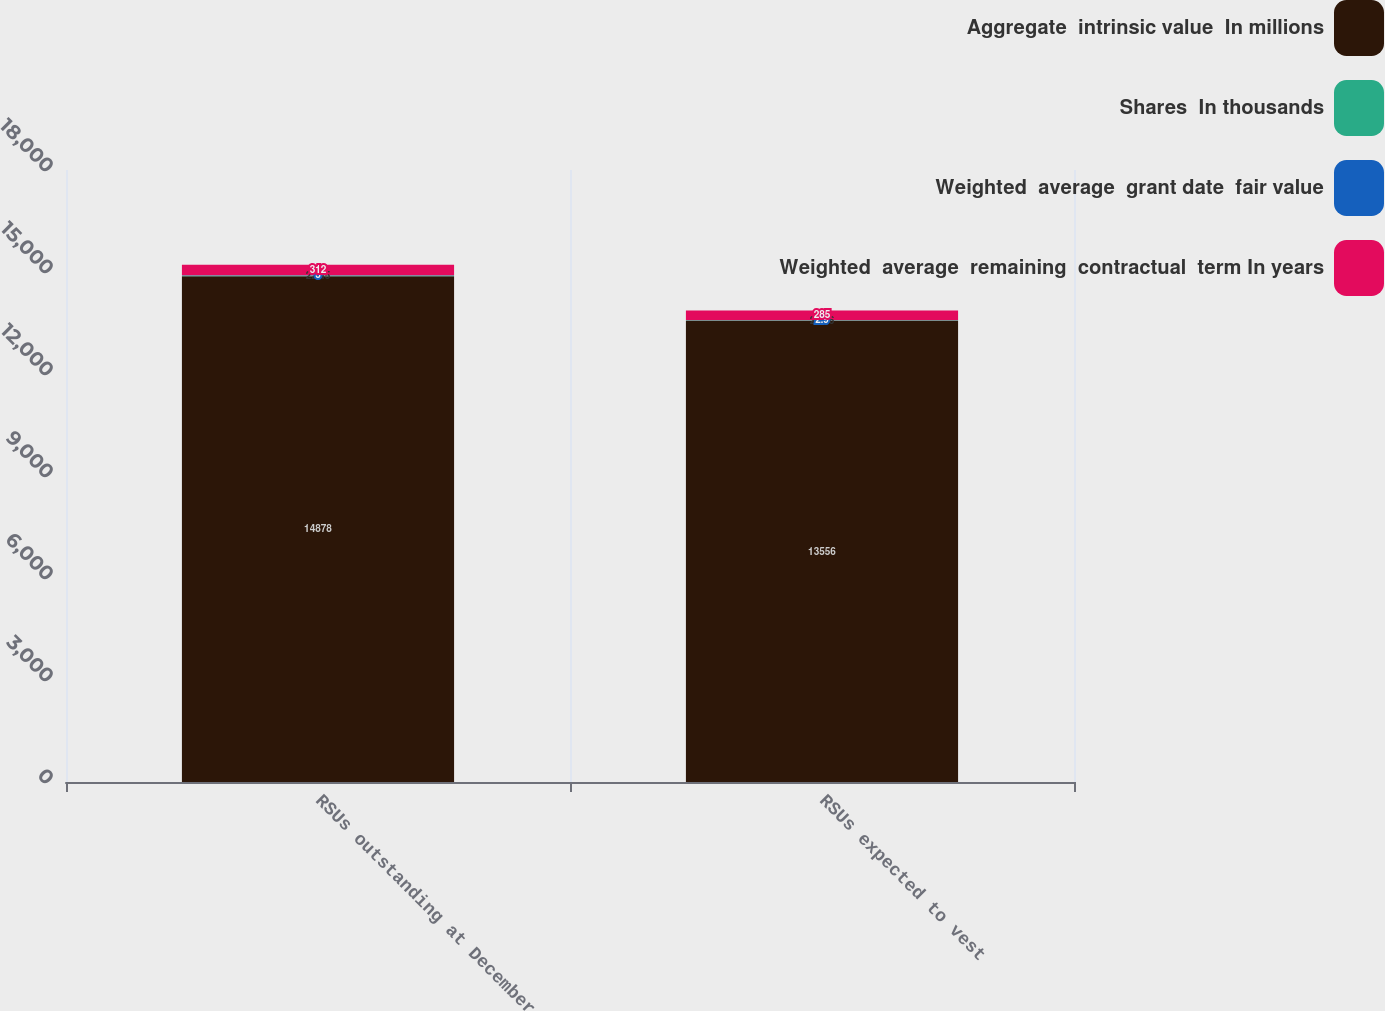<chart> <loc_0><loc_0><loc_500><loc_500><stacked_bar_chart><ecel><fcel>RSUs outstanding at December<fcel>RSUs expected to vest<nl><fcel>Aggregate  intrinsic value  In millions<fcel>14878<fcel>13556<nl><fcel>Shares  In thousands<fcel>22.45<fcel>22.46<nl><fcel>Weighted  average  grant date  fair value<fcel>3<fcel>2.9<nl><fcel>Weighted  average  remaining  contractual  term In years<fcel>312<fcel>285<nl></chart> 